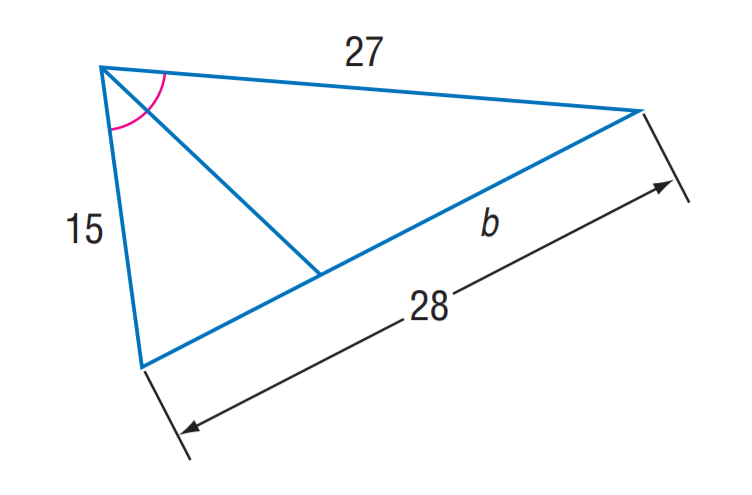Question: Find b.
Choices:
A. 15
B. 18
C. 24
D. 27
Answer with the letter. Answer: B 